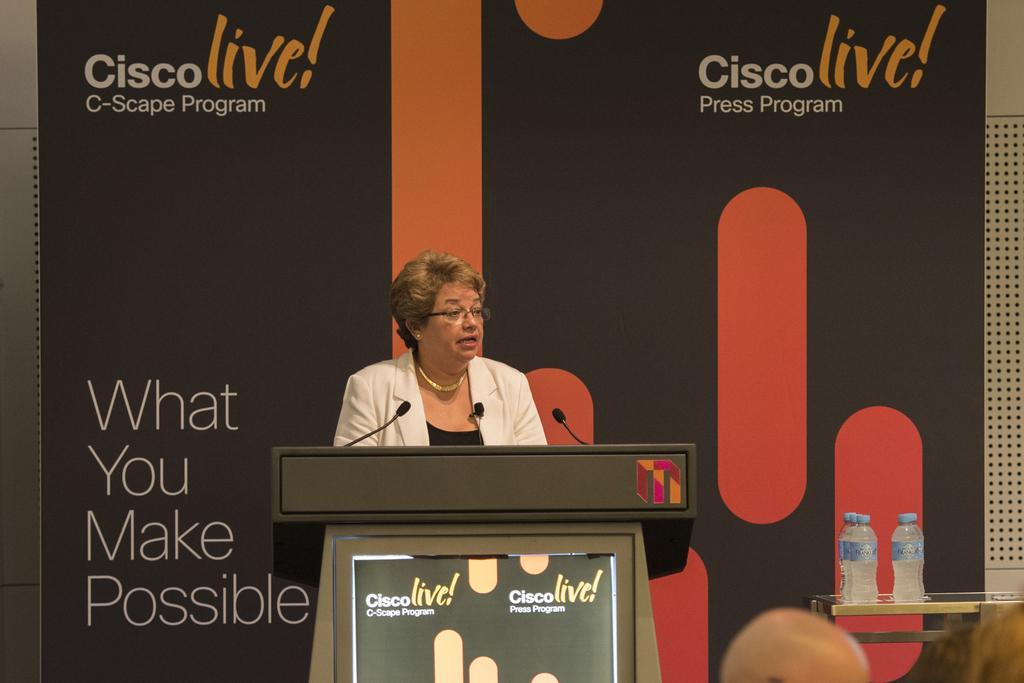Describe this image in one or two sentences. In the image we can see a woman wearing clothes, neck chain, spectacles, ear studs and the woman is talking. Here we can see a podium and microphones. Behind the woman there is a poster and text on the poster. We can see there are few water bottles on the table, we can see there are other people. 